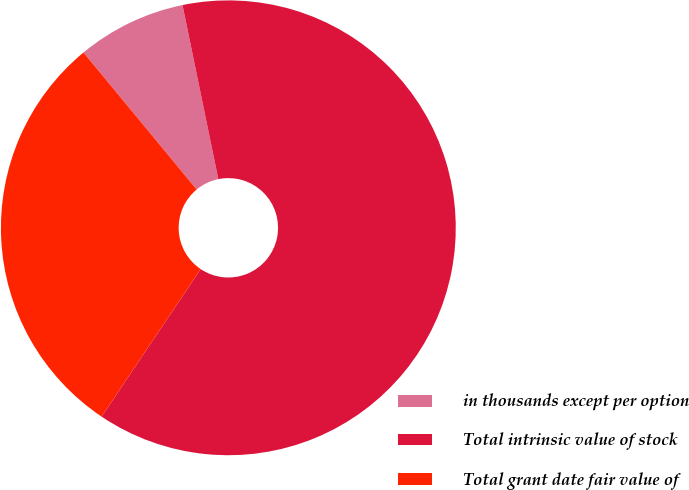Convert chart to OTSL. <chart><loc_0><loc_0><loc_500><loc_500><pie_chart><fcel>in thousands except per option<fcel>Total intrinsic value of stock<fcel>Total grant date fair value of<nl><fcel>7.76%<fcel>62.64%<fcel>29.6%<nl></chart> 